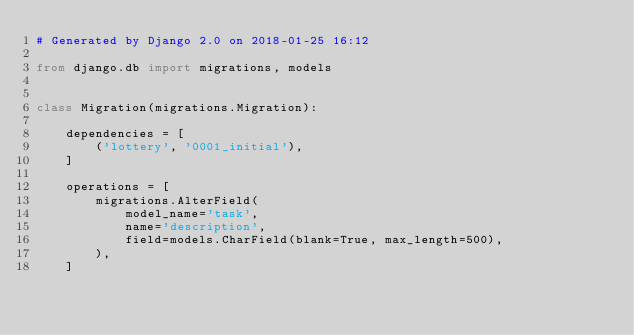<code> <loc_0><loc_0><loc_500><loc_500><_Python_># Generated by Django 2.0 on 2018-01-25 16:12

from django.db import migrations, models


class Migration(migrations.Migration):

    dependencies = [
        ('lottery', '0001_initial'),
    ]

    operations = [
        migrations.AlterField(
            model_name='task',
            name='description',
            field=models.CharField(blank=True, max_length=500),
        ),
    ]
</code> 